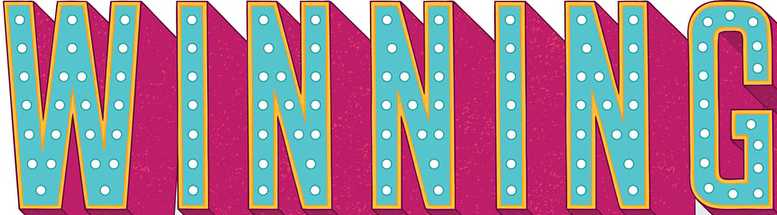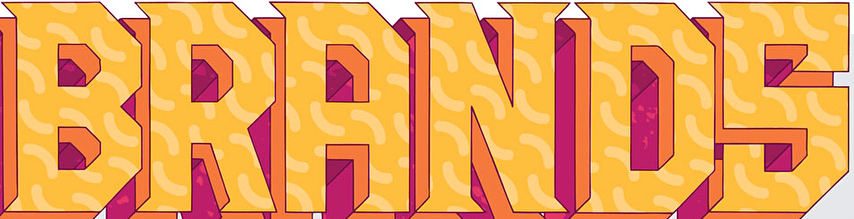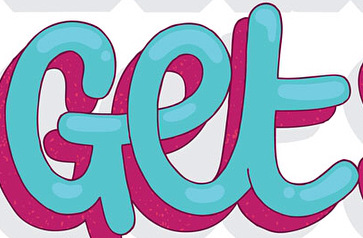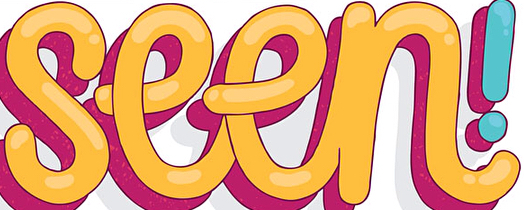What words are shown in these images in order, separated by a semicolon? WINNING; BRANDS; Get; seen 